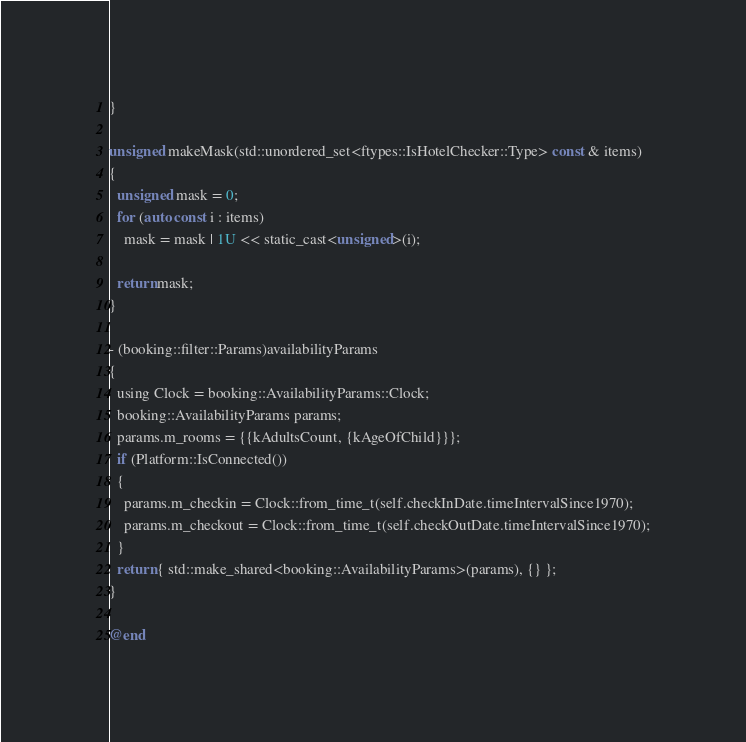Convert code to text. <code><loc_0><loc_0><loc_500><loc_500><_ObjectiveC_>}

unsigned makeMask(std::unordered_set<ftypes::IsHotelChecker::Type> const & items)
{
  unsigned mask = 0;
  for (auto const i : items)
    mask = mask | 1U << static_cast<unsigned>(i);
  
  return mask;
}

- (booking::filter::Params)availabilityParams
{
  using Clock = booking::AvailabilityParams::Clock;
  booking::AvailabilityParams params;
  params.m_rooms = {{kAdultsCount, {kAgeOfChild}}};
  if (Platform::IsConnected())
  {
    params.m_checkin = Clock::from_time_t(self.checkInDate.timeIntervalSince1970);
    params.m_checkout = Clock::from_time_t(self.checkOutDate.timeIntervalSince1970);
  }
  return { std::make_shared<booking::AvailabilityParams>(params), {} };
}

@end
</code> 